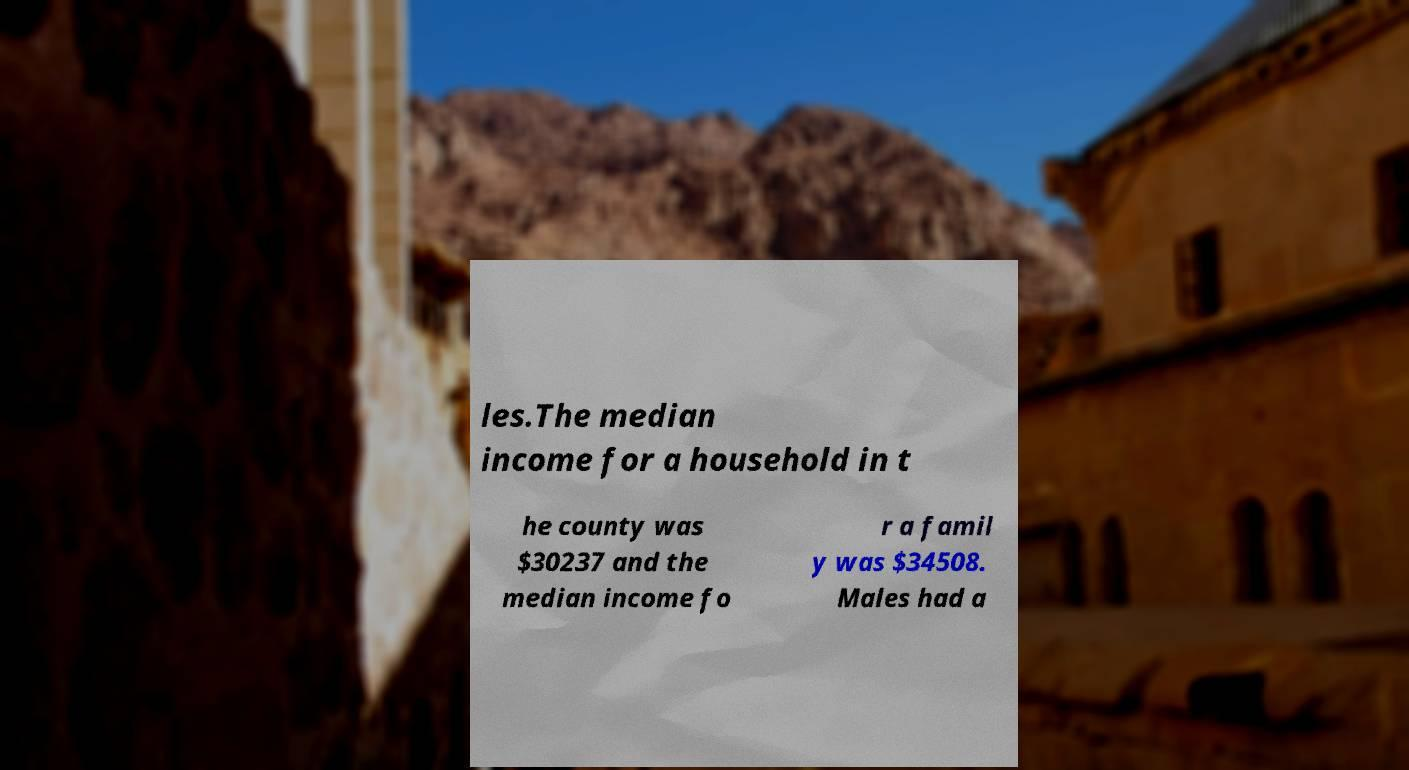Can you accurately transcribe the text from the provided image for me? les.The median income for a household in t he county was $30237 and the median income fo r a famil y was $34508. Males had a 